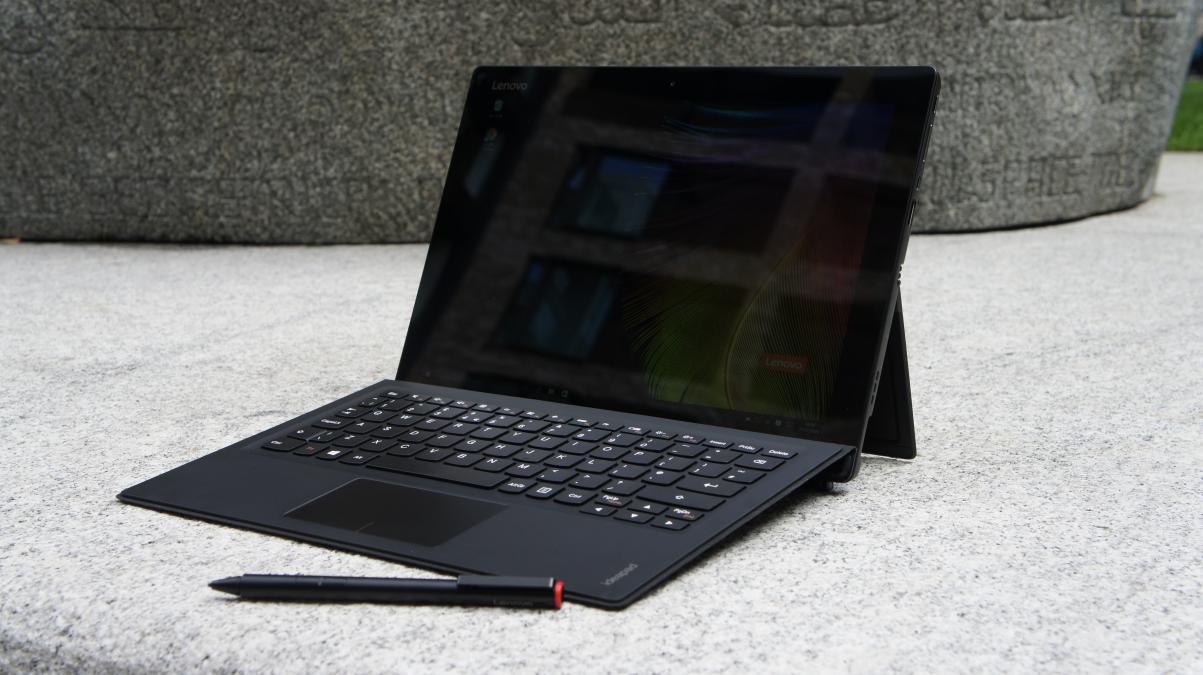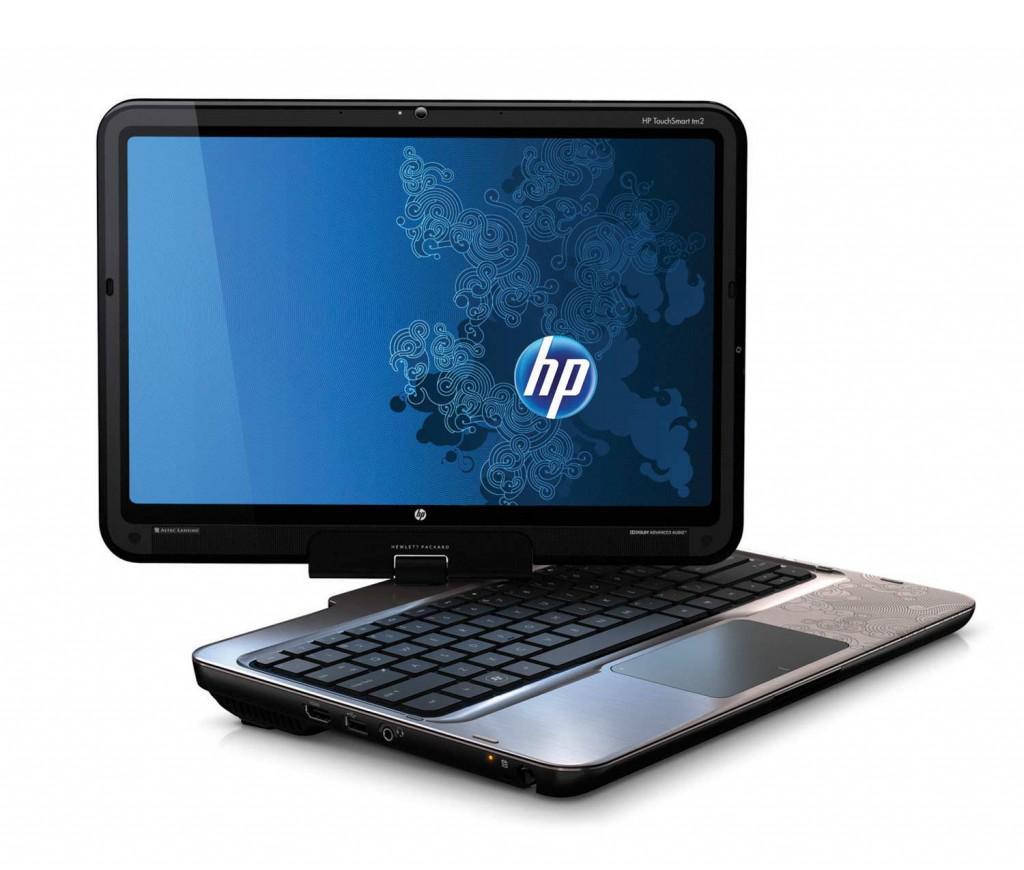The first image is the image on the left, the second image is the image on the right. For the images shown, is this caption "There are more laptop-type devices in the right image than in the left." true? Answer yes or no. No. 